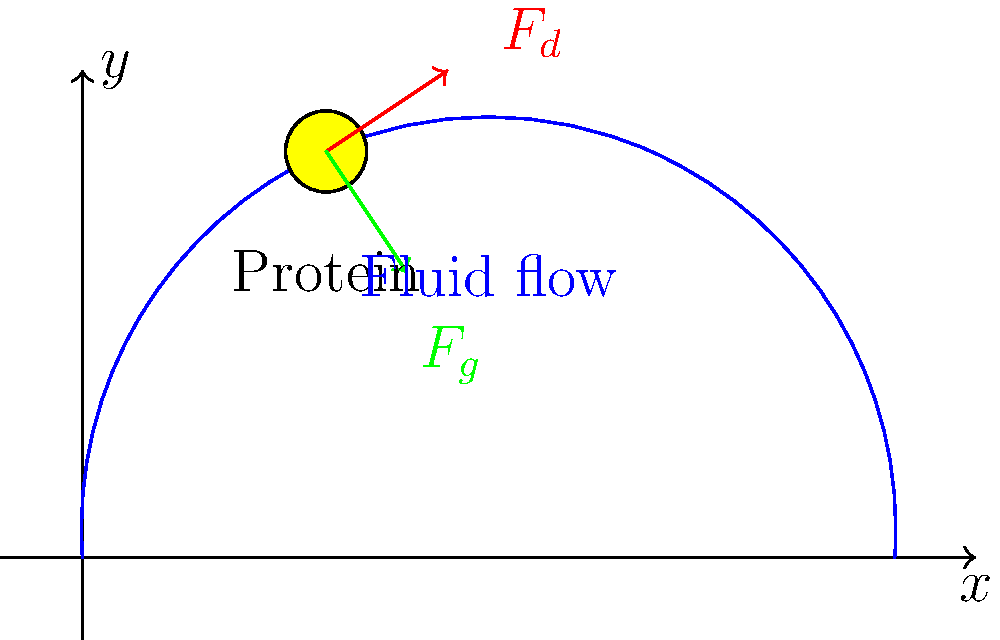A protein molecule is suspended in a fluid flowing from left to right, as shown in the diagram. The protein experiences a drag force $F_d$ (red arrow) and a gravitational force $F_g$ (green arrow). If the magnitude of the drag force is $3.5 \times 10^{-12}$ N and the gravitational force is $2.1 \times 10^{-12}$ N, what is the magnitude of the resultant force acting on the protein molecule? To find the magnitude of the resultant force, we need to follow these steps:

1) Identify the forces: We have two forces acting on the protein molecule:
   - Drag force ($F_d$): $3.5 \times 10^{-12}$ N
   - Gravitational force ($F_g$): $2.1 \times 10^{-12}$ N

2) Determine the direction of forces:
   - $F_d$ is acting diagonally upward and to the right
   - $F_g$ is acting straight downward

3) Resolve the forces into x and y components:
   - $F_d$: Let's assume it makes a 45° angle with the horizontal
     $F_{dx} = F_d \cos(45°) = 3.5 \times 10^{-12} \times \frac{\sqrt{2}}{2} = 2.47 \times 10^{-12}$ N
     $F_{dy} = F_d \sin(45°) = 3.5 \times 10^{-12} \times \frac{\sqrt{2}}{2} = 2.47 \times 10^{-12}$ N
   - $F_g$: Only has a y-component
     $F_{gy} = -2.1 \times 10^{-12}$ N (negative because it's downward)

4) Sum the forces in each direction:
   $F_x = F_{dx} = 2.47 \times 10^{-12}$ N
   $F_y = F_{dy} + F_{gy} = 2.47 \times 10^{-12} - 2.1 \times 10^{-12} = 0.37 \times 10^{-12}$ N

5) Calculate the magnitude of the resultant force using the Pythagorean theorem:
   $F_{resultant} = \sqrt{F_x^2 + F_y^2}$
   $F_{resultant} = \sqrt{(2.47 \times 10^{-12})^2 + (0.37 \times 10^{-12})^2}$
   $F_{resultant} = \sqrt{6.1009 \times 10^{-24} + 0.1369 \times 10^{-24}}$
   $F_{resultant} = \sqrt{6.2378 \times 10^{-24}}$
   $F_{resultant} = 2.50 \times 10^{-12}$ N

Therefore, the magnitude of the resultant force acting on the protein molecule is $2.50 \times 10^{-12}$ N.
Answer: $2.50 \times 10^{-12}$ N 